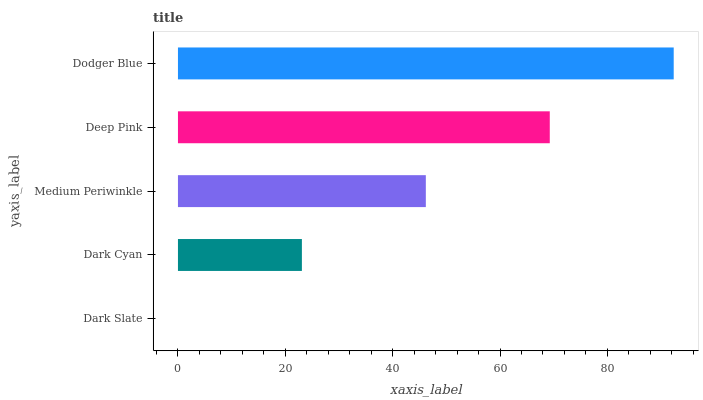Is Dark Slate the minimum?
Answer yes or no. Yes. Is Dodger Blue the maximum?
Answer yes or no. Yes. Is Dark Cyan the minimum?
Answer yes or no. No. Is Dark Cyan the maximum?
Answer yes or no. No. Is Dark Cyan greater than Dark Slate?
Answer yes or no. Yes. Is Dark Slate less than Dark Cyan?
Answer yes or no. Yes. Is Dark Slate greater than Dark Cyan?
Answer yes or no. No. Is Dark Cyan less than Dark Slate?
Answer yes or no. No. Is Medium Periwinkle the high median?
Answer yes or no. Yes. Is Medium Periwinkle the low median?
Answer yes or no. Yes. Is Dark Cyan the high median?
Answer yes or no. No. Is Dark Slate the low median?
Answer yes or no. No. 